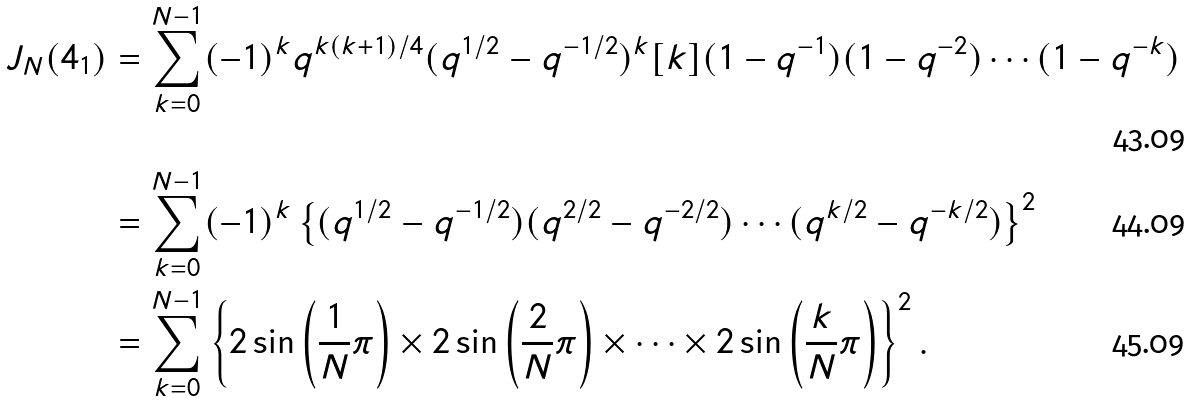Convert formula to latex. <formula><loc_0><loc_0><loc_500><loc_500>J _ { N } ( 4 _ { 1 } ) & = \sum _ { k = 0 } ^ { N - 1 } ( - 1 ) ^ { k } q ^ { k ( k + 1 ) / 4 } ( q ^ { 1 / 2 } - q ^ { - 1 / 2 } ) ^ { k } [ k ] ( 1 - q ^ { - 1 } ) ( 1 - q ^ { - 2 } ) \cdots ( 1 - q ^ { - k } ) \\ & = \sum _ { k = 0 } ^ { N - 1 } ( - 1 ) ^ { k } \left \{ ( q ^ { 1 / 2 } - q ^ { - 1 / 2 } ) ( q ^ { 2 / 2 } - q ^ { - 2 / 2 } ) \cdots ( q ^ { k / 2 } - q ^ { - k / 2 } ) \right \} ^ { 2 } \\ & = \sum _ { k = 0 } ^ { N - 1 } \left \{ 2 \sin \left ( \frac { 1 } { N } \pi \right ) \times 2 \sin \left ( \frac { 2 } { N } \pi \right ) \times \cdots \times 2 \sin \left ( \frac { k } { N } \pi \right ) \right \} ^ { 2 } .</formula> 